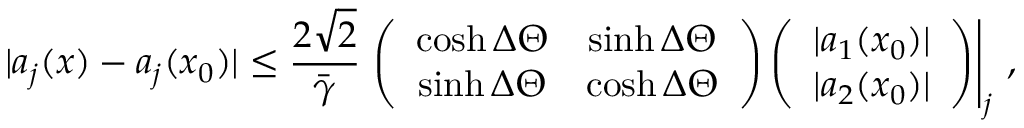Convert formula to latex. <formula><loc_0><loc_0><loc_500><loc_500>| a _ { j } ( x ) - a _ { j } ( x _ { 0 } ) | \leq \frac { 2 \sqrt { 2 } } { \bar { \gamma } } \left ( \begin{array} { c c } { \cosh \Delta \Theta } & { \sinh \Delta \Theta } \\ { \sinh \Delta \Theta } & { \cosh \Delta \Theta } \end{array} \right ) \left ( \begin{array} { c } { { | a _ { 1 } ( x _ { 0 } ) | } } \\ { { | a _ { 2 } ( x _ { 0 } ) | } } \end{array} \right ) \right | _ { j } \, ,</formula> 